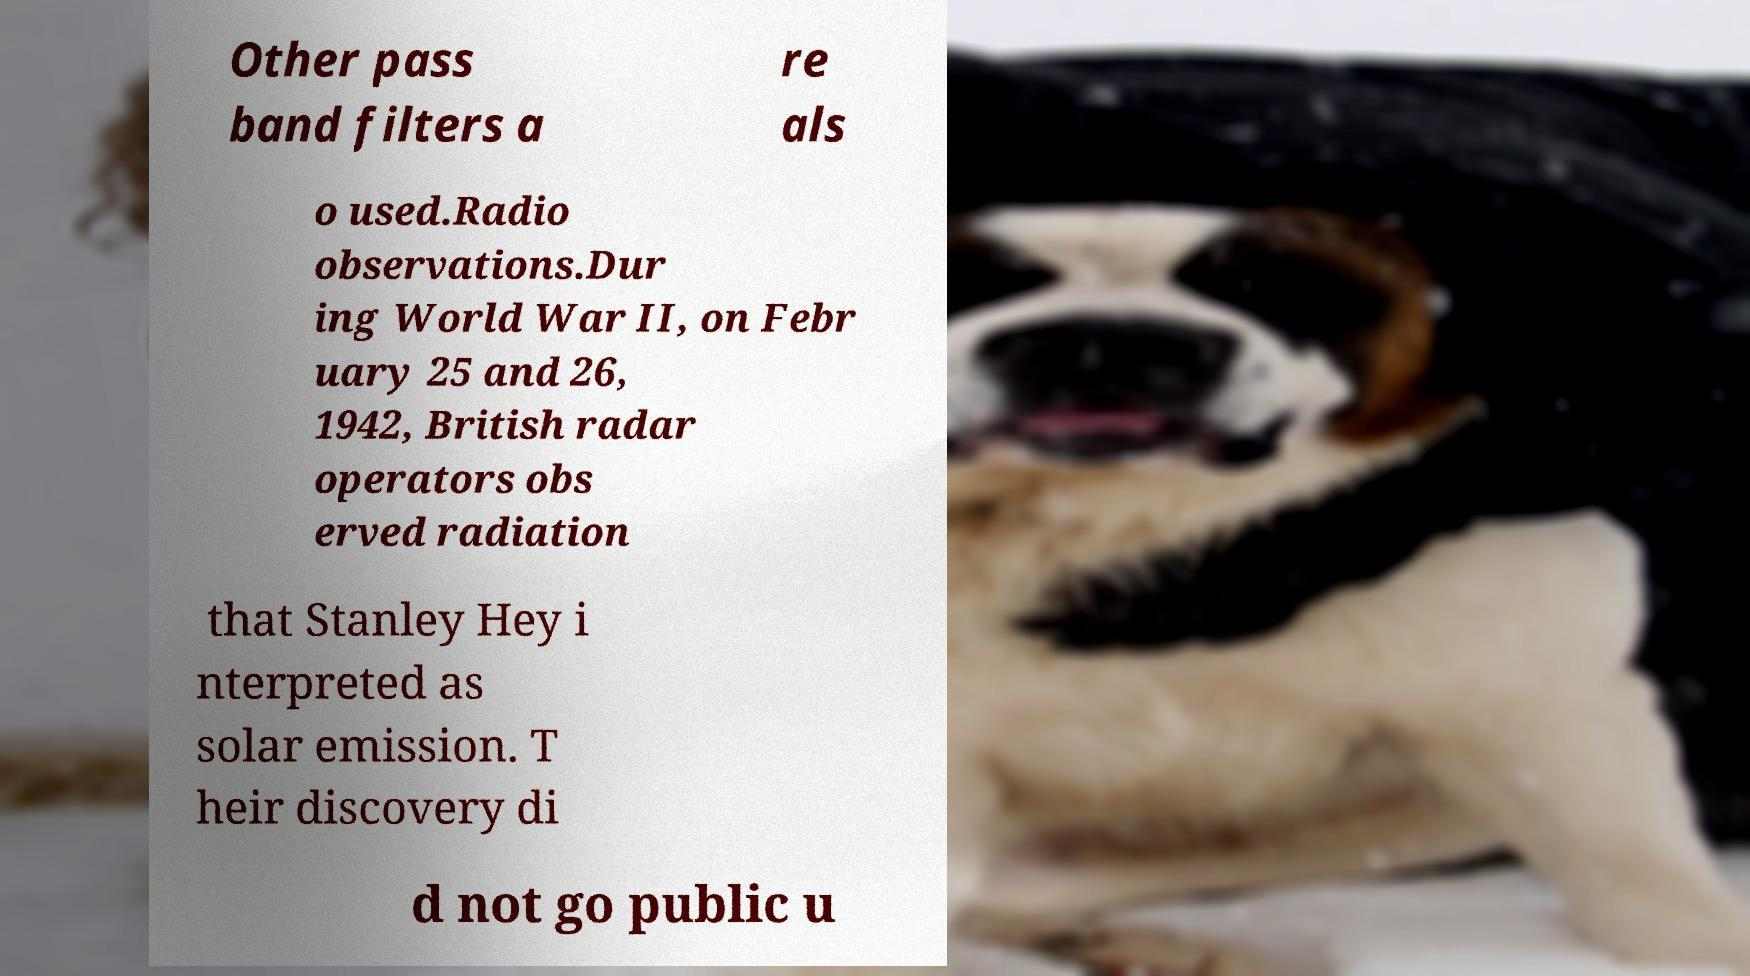Could you extract and type out the text from this image? Other pass band filters a re als o used.Radio observations.Dur ing World War II, on Febr uary 25 and 26, 1942, British radar operators obs erved radiation that Stanley Hey i nterpreted as solar emission. T heir discovery di d not go public u 